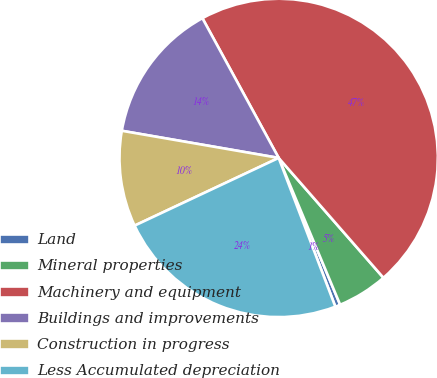Convert chart. <chart><loc_0><loc_0><loc_500><loc_500><pie_chart><fcel>Land<fcel>Mineral properties<fcel>Machinery and equipment<fcel>Buildings and improvements<fcel>Construction in progress<fcel>Less Accumulated depreciation<nl><fcel>0.52%<fcel>5.12%<fcel>46.52%<fcel>14.32%<fcel>9.72%<fcel>23.8%<nl></chart> 